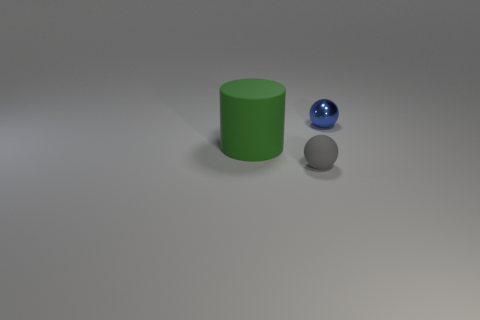Could you describe the ambiance or mood of this image? The image has a minimalist and serene quality, with neutral colors and soft lighting that creates a calm, introspective mood. 